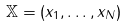Convert formula to latex. <formula><loc_0><loc_0><loc_500><loc_500>\mathbb { X } = ( x _ { 1 } , \dots , x _ { N } )</formula> 